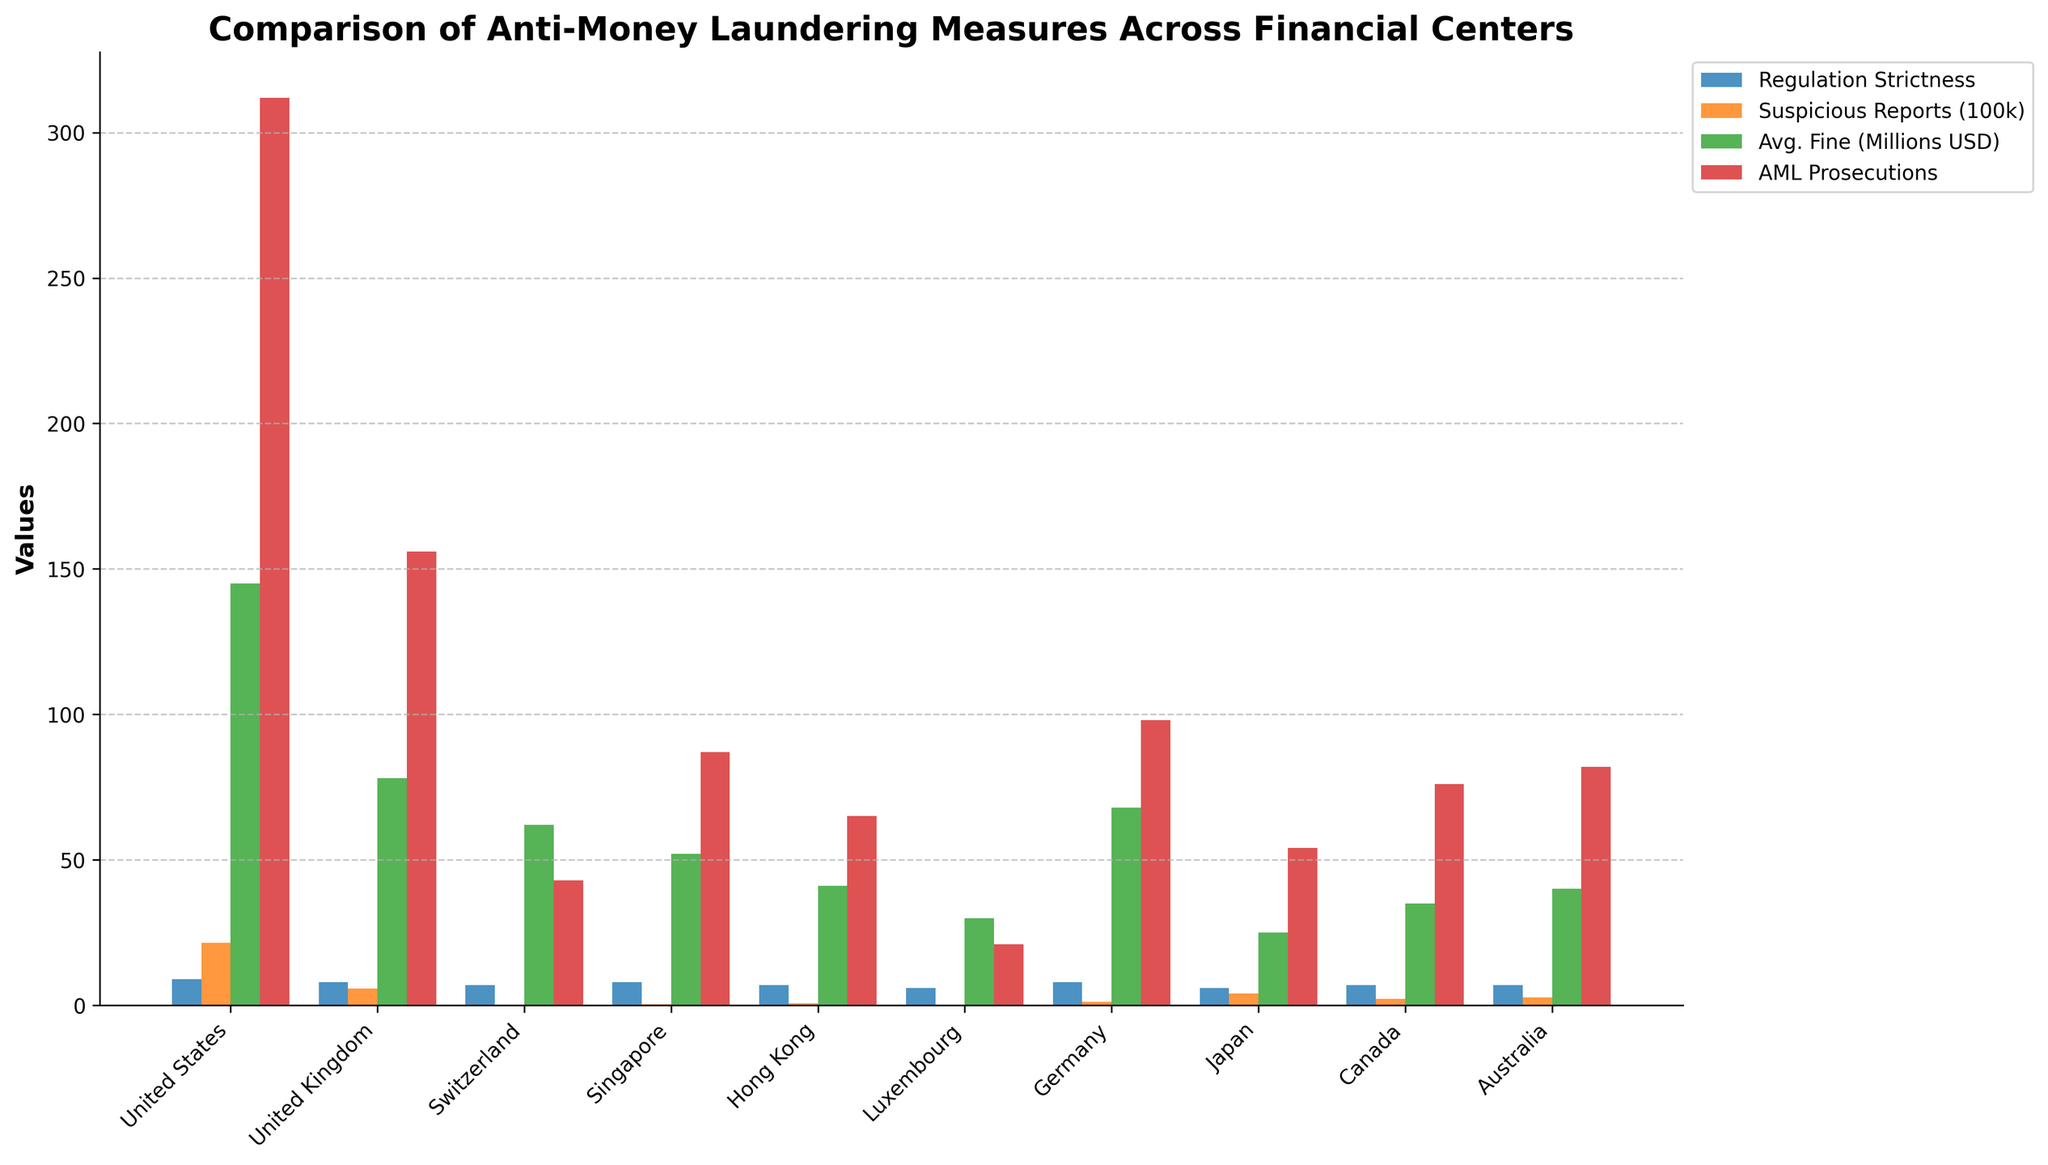Which country has the highest number of Suspicious Activity Reports filed? The country with the highest number of Suspicious Activity Reports can be identified by the tallest orange bar. The United States has the tallest bar in the orange category, indicating it has the highest number of reported suspicious activities.
Answer: United States Which country has the lowest average fine for AML violations? The country with the shortest green bar represents the lowest average fine for AML violations. Japan has the shortest green bar, indicating it has the lowest average fine.
Answer: Japan How does the AML regulation strictness score of Hong Kong compare to that of Switzerland? By comparing the height of the blue bars for both Hong Kong and Switzerland, we see that the blue bar for Hong Kong is at level 7, and the blue bar for Switzerland is also at level 7, indicating equal strictness.
Answer: Equal What's the sum of AML-related prosecutions in Singapore and Hong Kong? The height of the red bars signifies the number of AML-related prosecutions. Singapore has 87 prosecutions, and Hong Kong has 65. Summing these gives 87 + 65.
Answer: 152 Which countries have an AML regulation strictness score of 8? By looking at the height of the blue bars, we can identify that the blue bars for the United Kingdom, Singapore, and Germany are at level 8, indicating they have a strictness score of 8.
Answer: United Kingdom, Singapore, Germany Which country has the largest difference between AML regulation strictness and the number of AML-related prosecutions? To determine the difference, compare the blue and red bar heights. The United States has a regulation strictness of 9 and 312 prosecutions. Its difference of 303 is the largest among the countries.
Answer: United States Is the average fine for AML violations higher in Canada or Australia? By comparing the height of the green bars for Canada and Australia, we see that the green bar for Canada is at 35 and for Australia, it is at 40. Hence, Australia has a higher average fine for AML violations.
Answer: Australia How does Luxembourg's Number of Suspicious Activity Reports compare to Singapore's? Compare the height of the orange bars for Luxembourg (11k) and Singapore (35k). Singapore’s bar is taller, indicating it has a higher number of suspicious activity reports filed.
Answer: Singapore has more What is the combined AML regulation strictness score of Canada, Switzerland, and Germany? The regulation strictness scores are tallied from the blue bars: Canada (7), Switzerland (7), Germany (8). Summing these scores gives 7 + 7 + 8.
Answer: 22 